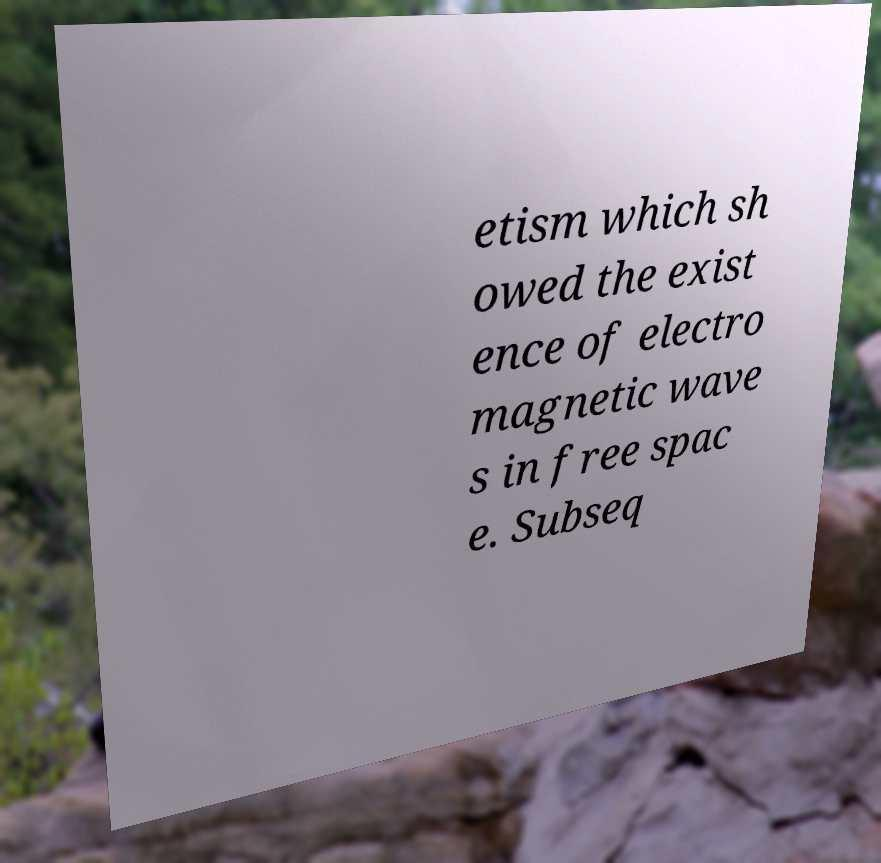Please identify and transcribe the text found in this image. etism which sh owed the exist ence of electro magnetic wave s in free spac e. Subseq 